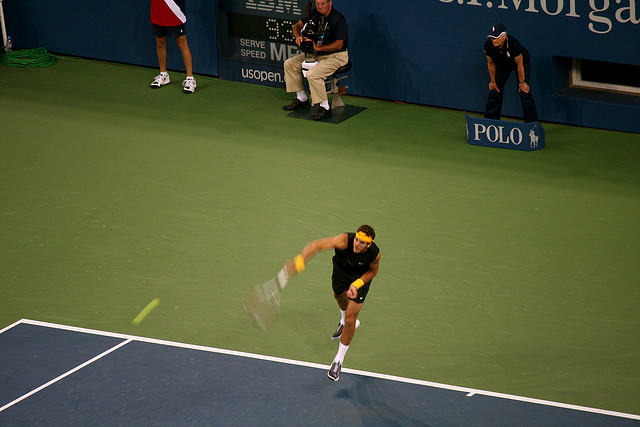Identify and read out the text in this image. POLO usopen. SPEED 93 SERVE IBM M 